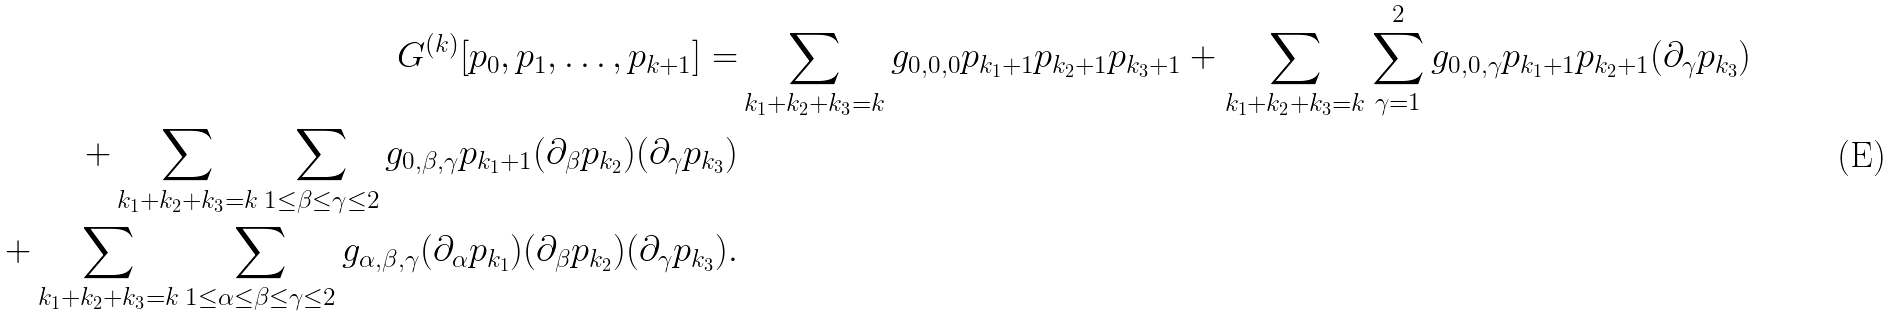<formula> <loc_0><loc_0><loc_500><loc_500>G ^ { ( k ) } [ p _ { 0 } , p _ { 1 } , \dots , p _ { k + 1 } ] = & \sum _ { k _ { 1 } + k _ { 2 } + k _ { 3 } = k } g _ { 0 , 0 , 0 } p _ { k _ { 1 } + 1 } p _ { k _ { 2 } + 1 } p _ { k _ { 3 } + 1 } + \sum _ { k _ { 1 } + k _ { 2 } + k _ { 3 } = k } \sum _ { \gamma = 1 } ^ { 2 } g _ { 0 , 0 , \gamma } p _ { k _ { 1 } + 1 } p _ { k _ { 2 } + 1 } ( \partial _ { \gamma } p _ { k _ { 3 } } ) \\ + \sum _ { k _ { 1 } + k _ { 2 } + k _ { 3 } = k } \sum _ { 1 \leq \beta \leq \gamma \leq 2 } g _ { 0 , \beta , \gamma } p _ { k _ { 1 } + 1 } ( \partial _ { \beta } p _ { k _ { 2 } } ) ( \partial _ { \gamma } p _ { k _ { 3 } } ) \\ + \sum _ { k _ { 1 } + k _ { 2 } + k _ { 3 } = k } \sum _ { 1 \leq \alpha \leq \beta \leq \gamma \leq 2 } g _ { \alpha , \beta , \gamma } ( \partial _ { \alpha } p _ { k _ { 1 } } ) ( \partial _ { \beta } p _ { k _ { 2 } } ) ( \partial _ { \gamma } p _ { k _ { 3 } } ) .</formula> 